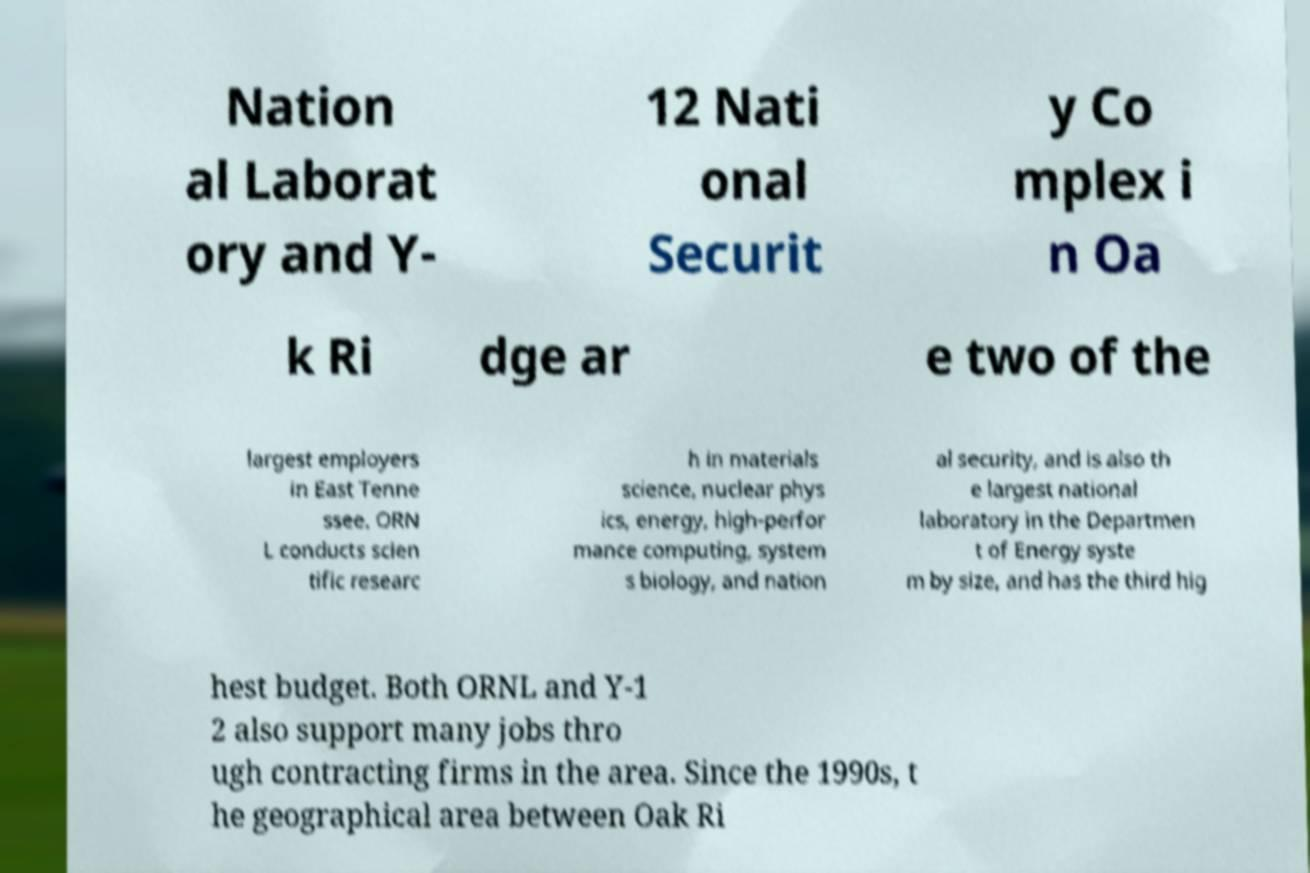For documentation purposes, I need the text within this image transcribed. Could you provide that? Nation al Laborat ory and Y- 12 Nati onal Securit y Co mplex i n Oa k Ri dge ar e two of the largest employers in East Tenne ssee. ORN L conducts scien tific researc h in materials science, nuclear phys ics, energy, high-perfor mance computing, system s biology, and nation al security, and is also th e largest national laboratory in the Departmen t of Energy syste m by size, and has the third hig hest budget. Both ORNL and Y-1 2 also support many jobs thro ugh contracting firms in the area. Since the 1990s, t he geographical area between Oak Ri 